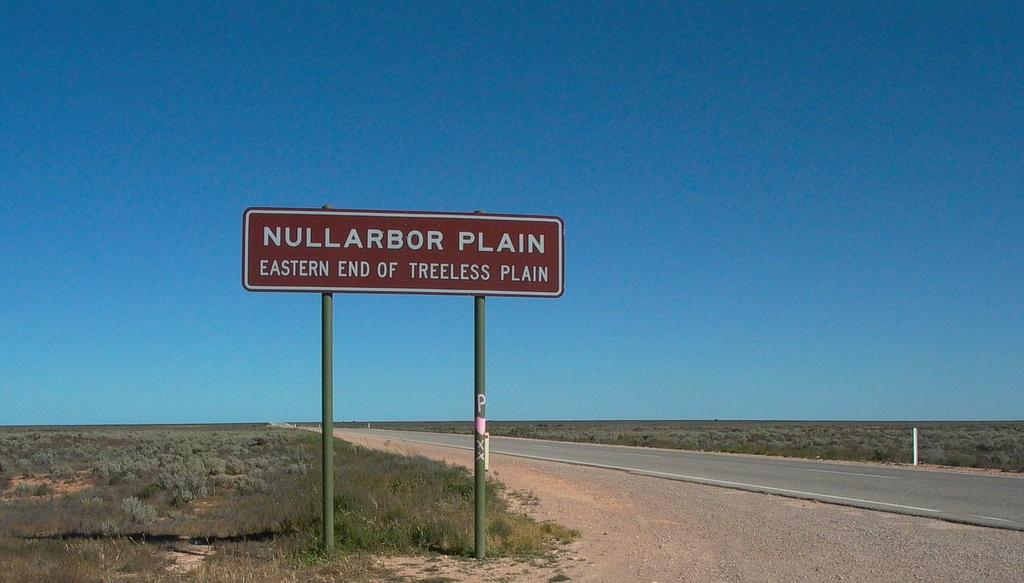<image>
Share a concise interpretation of the image provided. the brown sign along the road shows the eastern end of the treeless plain 